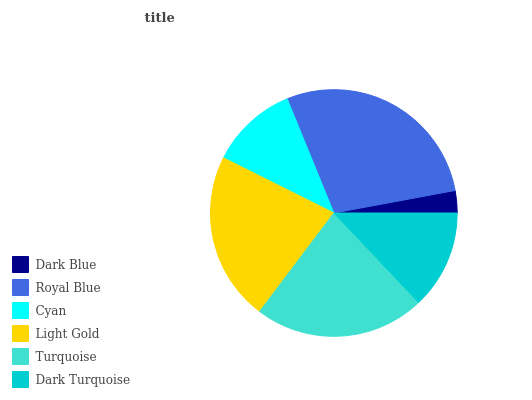Is Dark Blue the minimum?
Answer yes or no. Yes. Is Royal Blue the maximum?
Answer yes or no. Yes. Is Cyan the minimum?
Answer yes or no. No. Is Cyan the maximum?
Answer yes or no. No. Is Royal Blue greater than Cyan?
Answer yes or no. Yes. Is Cyan less than Royal Blue?
Answer yes or no. Yes. Is Cyan greater than Royal Blue?
Answer yes or no. No. Is Royal Blue less than Cyan?
Answer yes or no. No. Is Light Gold the high median?
Answer yes or no. Yes. Is Dark Turquoise the low median?
Answer yes or no. Yes. Is Dark Turquoise the high median?
Answer yes or no. No. Is Cyan the low median?
Answer yes or no. No. 